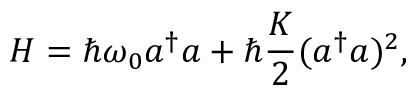Convert formula to latex. <formula><loc_0><loc_0><loc_500><loc_500>H = \hbar { \omega } _ { 0 } a ^ { \dagger } a + \hbar { } K } { 2 } ( a ^ { \dagger } a ) ^ { 2 } ,</formula> 